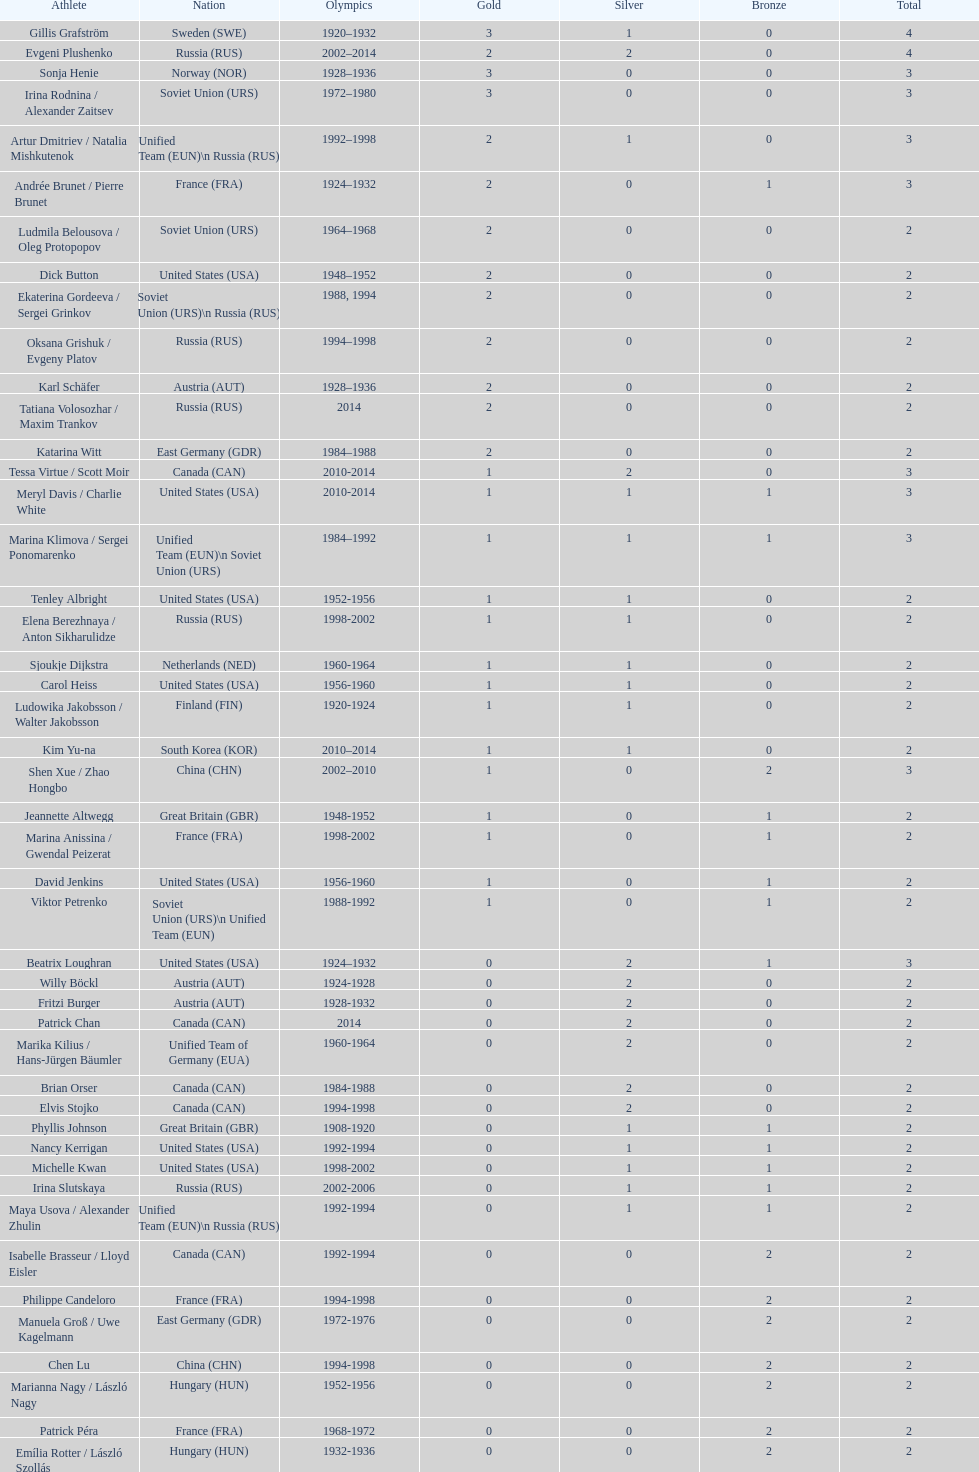How many total medals has the united states won in women's figure skating? 16. 